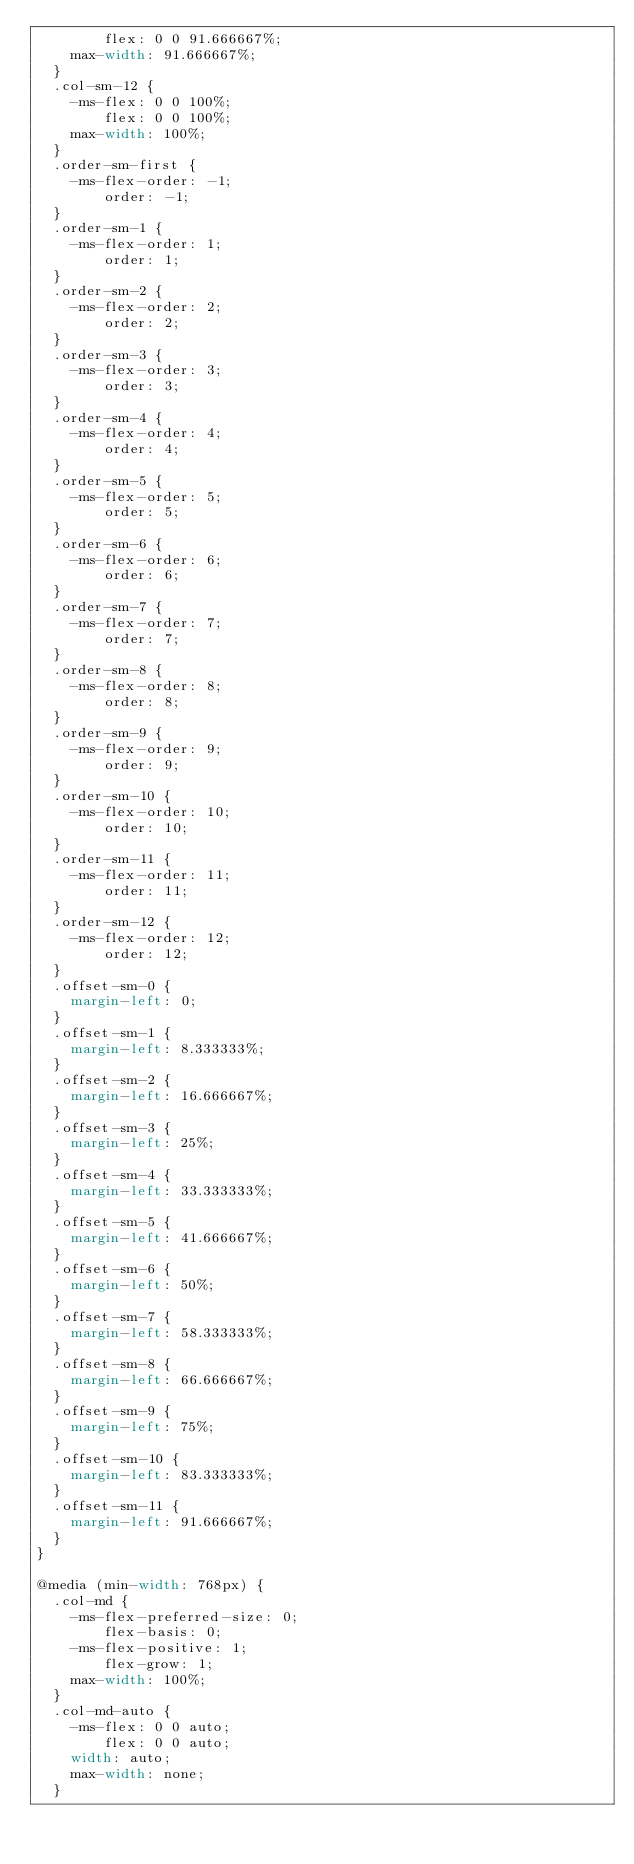Convert code to text. <code><loc_0><loc_0><loc_500><loc_500><_CSS_>        flex: 0 0 91.666667%;
    max-width: 91.666667%;
  }
  .col-sm-12 {
    -ms-flex: 0 0 100%;
        flex: 0 0 100%;
    max-width: 100%;
  }
  .order-sm-first {
    -ms-flex-order: -1;
        order: -1;
  }
  .order-sm-1 {
    -ms-flex-order: 1;
        order: 1;
  }
  .order-sm-2 {
    -ms-flex-order: 2;
        order: 2;
  }
  .order-sm-3 {
    -ms-flex-order: 3;
        order: 3;
  }
  .order-sm-4 {
    -ms-flex-order: 4;
        order: 4;
  }
  .order-sm-5 {
    -ms-flex-order: 5;
        order: 5;
  }
  .order-sm-6 {
    -ms-flex-order: 6;
        order: 6;
  }
  .order-sm-7 {
    -ms-flex-order: 7;
        order: 7;
  }
  .order-sm-8 {
    -ms-flex-order: 8;
        order: 8;
  }
  .order-sm-9 {
    -ms-flex-order: 9;
        order: 9;
  }
  .order-sm-10 {
    -ms-flex-order: 10;
        order: 10;
  }
  .order-sm-11 {
    -ms-flex-order: 11;
        order: 11;
  }
  .order-sm-12 {
    -ms-flex-order: 12;
        order: 12;
  }
  .offset-sm-0 {
    margin-left: 0;
  }
  .offset-sm-1 {
    margin-left: 8.333333%;
  }
  .offset-sm-2 {
    margin-left: 16.666667%;
  }
  .offset-sm-3 {
    margin-left: 25%;
  }
  .offset-sm-4 {
    margin-left: 33.333333%;
  }
  .offset-sm-5 {
    margin-left: 41.666667%;
  }
  .offset-sm-6 {
    margin-left: 50%;
  }
  .offset-sm-7 {
    margin-left: 58.333333%;
  }
  .offset-sm-8 {
    margin-left: 66.666667%;
  }
  .offset-sm-9 {
    margin-left: 75%;
  }
  .offset-sm-10 {
    margin-left: 83.333333%;
  }
  .offset-sm-11 {
    margin-left: 91.666667%;
  }
}

@media (min-width: 768px) {
  .col-md {
    -ms-flex-preferred-size: 0;
        flex-basis: 0;
    -ms-flex-positive: 1;
        flex-grow: 1;
    max-width: 100%;
  }
  .col-md-auto {
    -ms-flex: 0 0 auto;
        flex: 0 0 auto;
    width: auto;
    max-width: none;
  }</code> 